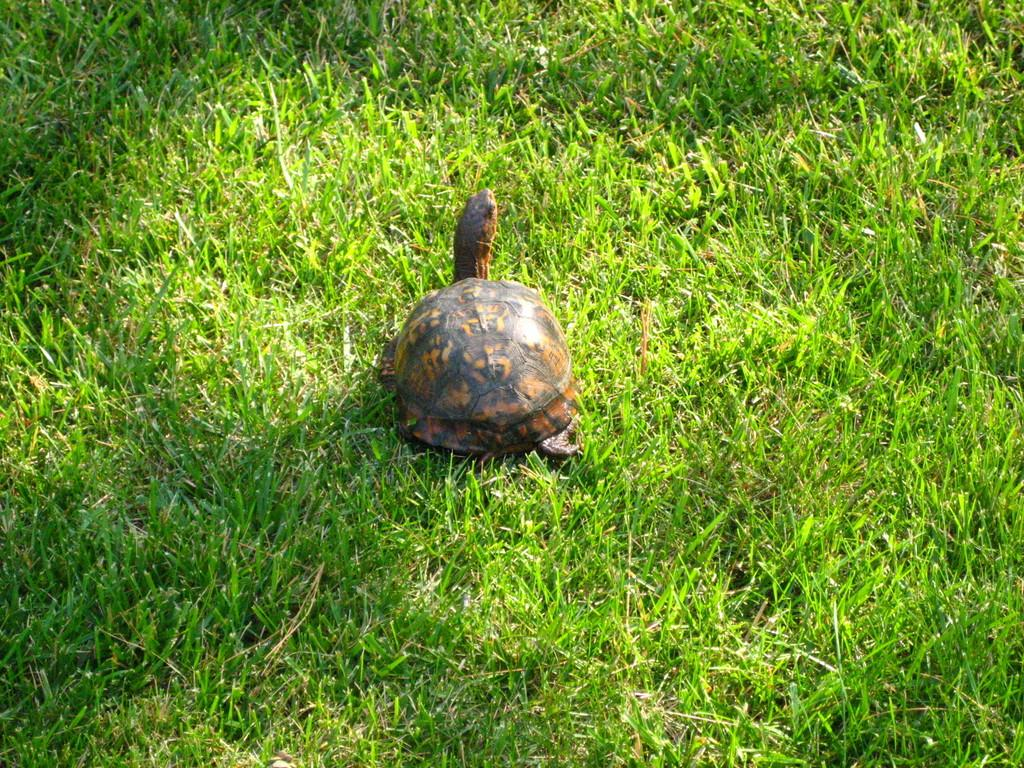What animal is present in the image? There is a turtle in the image. What is the color of the turtle? The turtle is brown in color. What type of vegetation can be seen at the bottom of the image? There is green grass at the bottom of the image. What type of beam is supporting the road in the image? There is no beam or road present in the image; it features a brown turtle and green grass. 